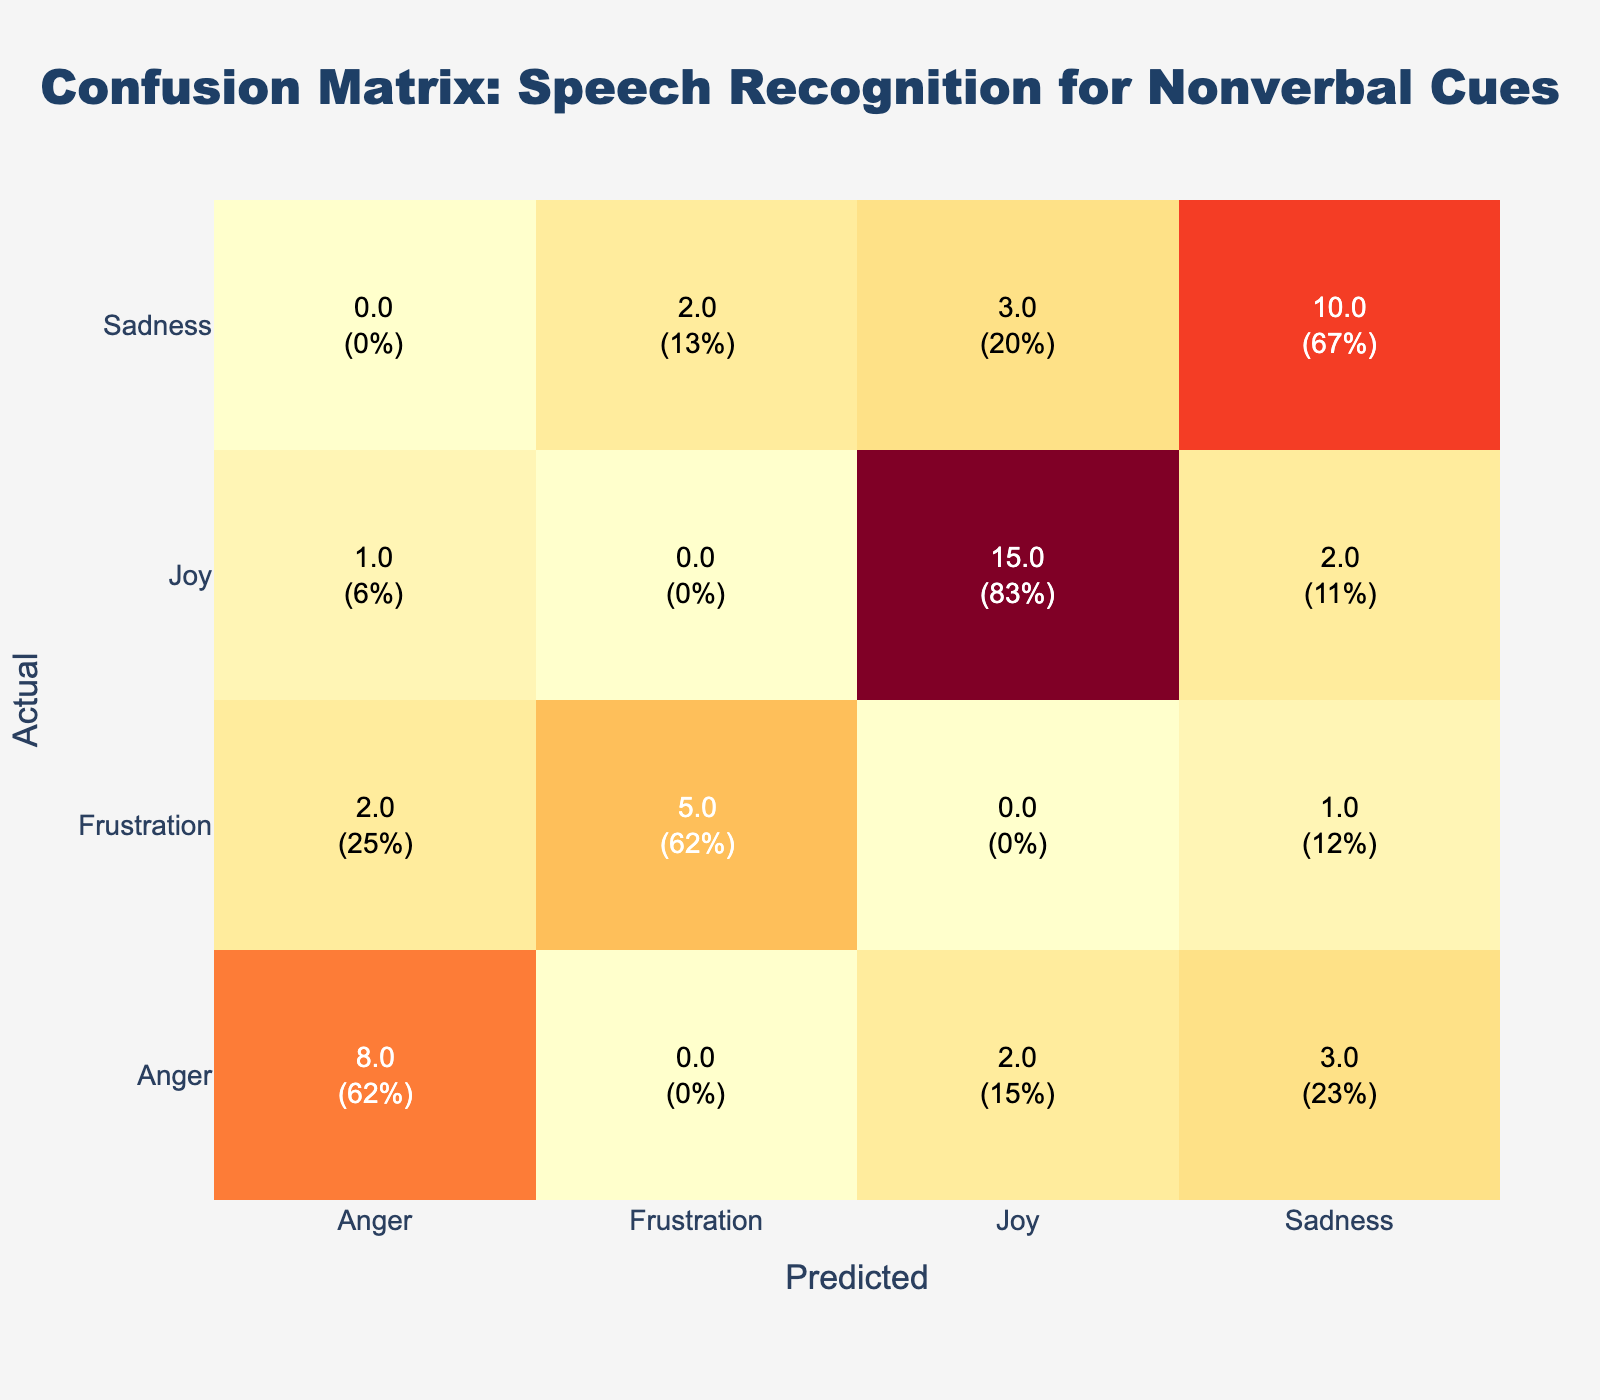What is the total count of instances where "Joy" was predicted incorrectly? To find this, we look at the row for "Joy" in the predicted column. There are two instances where the actual emotion is "Joy" but the predicted emotions are "Sadness" (2 instances) and "Anger" (1 instance). Therefore, the total incorrect predictions for "Joy" is 2 + 1 = 3.
Answer: 3 What percentage of the actual "Sadness" instances were predicted as "Joy"? The total number of actual "Sadness" instances is 10 (correct predictions) + 3 (predicted as "Joy") + 2 (predicted as "Frustration") = 15. The count predicted as "Joy" is 3. To get the percentage, we calculate (3 / 15) * 100 = 20%.
Answer: 20% Is the prediction of "Anger" more accurate than "Frustration"? For "Anger," there are 8 correct predictions (Anger as Anger), which is 8 out of 13 total instances (8 correct + 3 as Sadness + 2 as Joy). This gives about 61.54% accuracy. For "Frustration," there are 5 correct predictions (Frustration as Frustration) out of 8 total instances (5 correct + 1 as Sadness + 2 as Anger), giving a 62.5% accuracy. Thus, the prediction of "Frustration" is actually slightly more accurate.
Answer: No What is the total count of predictions made for "Joy"? To find this, we sum all the counts in the "Joy" column across all rows, which includes 15 for correct predictions (Joy as Joy) + 3 for mispredicted instances (Sadness as Joy) + 2 (Anger as Joy) = 20.
Answer: 20 How many instances were predicted as "Frustration" in total? We will sum the values in the "Frustration" row: 5 (correct predictions) + 1 (Sadness as Frustration) + 2 (Anger as Frustration) = 8.
Answer: 8 What is the proportion of "Joy" predicted correctly compared to the total "Joy" instances? There were 15 correct predictions of "Joy" and 3 incorrect ones predicting "Sadness" and 1 predicting "Anger". So, total instances of "Joy" is 15 + 3 + 1 = 19. The proportion of correct predictions is 15 / 19 ≈ 0.789 or 78.9%.
Answer: 78.9% 